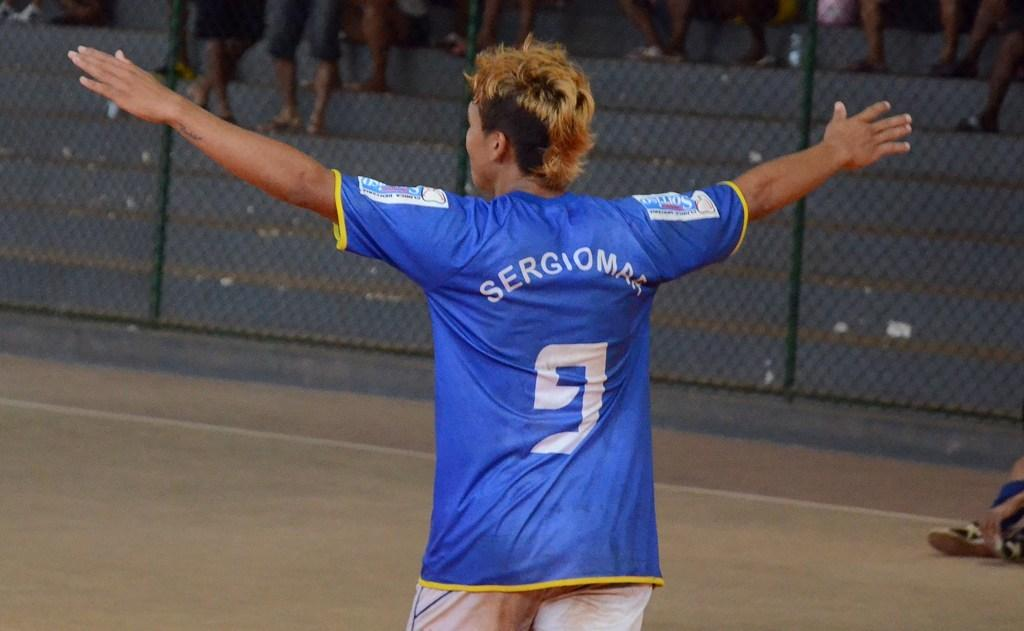<image>
Provide a brief description of the given image. A person wearing the number 9 on the back of their blue jersey is walking off a field. 